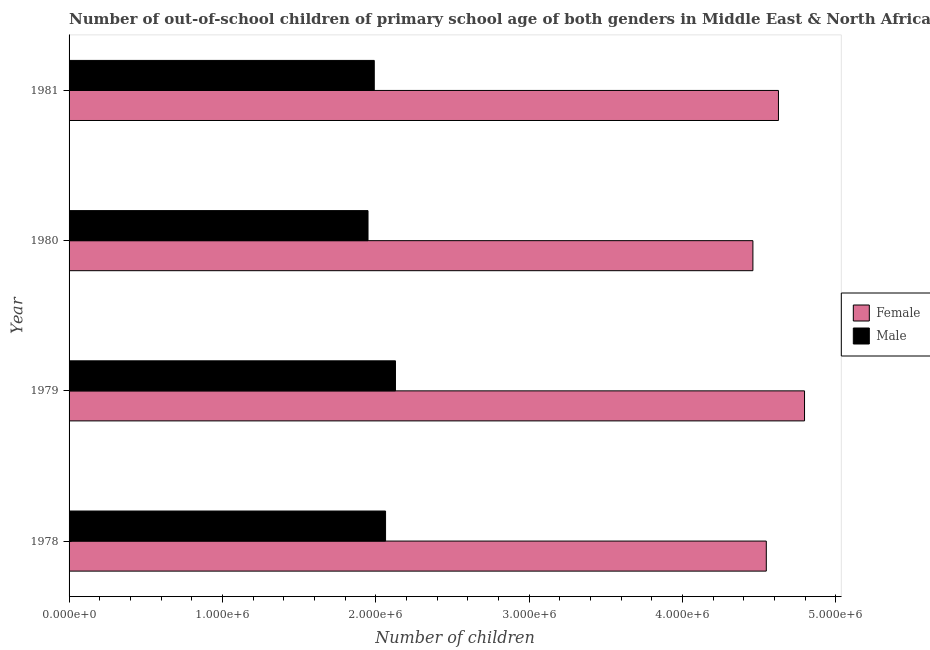How many bars are there on the 2nd tick from the top?
Offer a very short reply. 2. How many bars are there on the 3rd tick from the bottom?
Your response must be concise. 2. What is the label of the 3rd group of bars from the top?
Your answer should be very brief. 1979. In how many cases, is the number of bars for a given year not equal to the number of legend labels?
Ensure brevity in your answer.  0. What is the number of female out-of-school students in 1978?
Make the answer very short. 4.55e+06. Across all years, what is the maximum number of female out-of-school students?
Make the answer very short. 4.80e+06. Across all years, what is the minimum number of female out-of-school students?
Provide a succinct answer. 4.46e+06. In which year was the number of female out-of-school students maximum?
Offer a very short reply. 1979. What is the total number of female out-of-school students in the graph?
Your answer should be very brief. 1.84e+07. What is the difference between the number of female out-of-school students in 1978 and that in 1979?
Your answer should be very brief. -2.49e+05. What is the difference between the number of male out-of-school students in 1979 and the number of female out-of-school students in 1978?
Ensure brevity in your answer.  -2.42e+06. What is the average number of female out-of-school students per year?
Your response must be concise. 4.61e+06. In the year 1979, what is the difference between the number of male out-of-school students and number of female out-of-school students?
Provide a succinct answer. -2.67e+06. What is the ratio of the number of female out-of-school students in 1978 to that in 1979?
Give a very brief answer. 0.95. Is the number of female out-of-school students in 1979 less than that in 1980?
Your response must be concise. No. What is the difference between the highest and the second highest number of female out-of-school students?
Provide a succinct answer. 1.70e+05. What is the difference between the highest and the lowest number of male out-of-school students?
Your answer should be very brief. 1.79e+05. In how many years, is the number of male out-of-school students greater than the average number of male out-of-school students taken over all years?
Your response must be concise. 2. What does the 2nd bar from the top in 1979 represents?
Provide a short and direct response. Female. What does the 2nd bar from the bottom in 1981 represents?
Offer a very short reply. Male. How many bars are there?
Your response must be concise. 8. Are all the bars in the graph horizontal?
Make the answer very short. Yes. Are the values on the major ticks of X-axis written in scientific E-notation?
Your answer should be very brief. Yes. How many legend labels are there?
Offer a very short reply. 2. How are the legend labels stacked?
Your answer should be compact. Vertical. What is the title of the graph?
Give a very brief answer. Number of out-of-school children of primary school age of both genders in Middle East & North Africa (developing only). Does "Fertility rate" appear as one of the legend labels in the graph?
Your answer should be compact. No. What is the label or title of the X-axis?
Ensure brevity in your answer.  Number of children. What is the Number of children in Female in 1978?
Provide a short and direct response. 4.55e+06. What is the Number of children of Male in 1978?
Provide a short and direct response. 2.06e+06. What is the Number of children in Female in 1979?
Provide a succinct answer. 4.80e+06. What is the Number of children in Male in 1979?
Give a very brief answer. 2.13e+06. What is the Number of children in Female in 1980?
Your answer should be compact. 4.46e+06. What is the Number of children of Male in 1980?
Your response must be concise. 1.95e+06. What is the Number of children in Female in 1981?
Your answer should be compact. 4.63e+06. What is the Number of children of Male in 1981?
Your answer should be very brief. 1.99e+06. Across all years, what is the maximum Number of children of Female?
Give a very brief answer. 4.80e+06. Across all years, what is the maximum Number of children of Male?
Give a very brief answer. 2.13e+06. Across all years, what is the minimum Number of children in Female?
Provide a short and direct response. 4.46e+06. Across all years, what is the minimum Number of children in Male?
Your answer should be very brief. 1.95e+06. What is the total Number of children of Female in the graph?
Your answer should be compact. 1.84e+07. What is the total Number of children of Male in the graph?
Your answer should be very brief. 8.13e+06. What is the difference between the Number of children of Female in 1978 and that in 1979?
Offer a very short reply. -2.49e+05. What is the difference between the Number of children in Male in 1978 and that in 1979?
Make the answer very short. -6.46e+04. What is the difference between the Number of children of Female in 1978 and that in 1980?
Offer a very short reply. 8.73e+04. What is the difference between the Number of children in Male in 1978 and that in 1980?
Give a very brief answer. 1.14e+05. What is the difference between the Number of children of Female in 1978 and that in 1981?
Offer a very short reply. -7.93e+04. What is the difference between the Number of children of Male in 1978 and that in 1981?
Your answer should be very brief. 7.36e+04. What is the difference between the Number of children in Female in 1979 and that in 1980?
Provide a short and direct response. 3.37e+05. What is the difference between the Number of children in Male in 1979 and that in 1980?
Give a very brief answer. 1.79e+05. What is the difference between the Number of children of Female in 1979 and that in 1981?
Offer a very short reply. 1.70e+05. What is the difference between the Number of children of Male in 1979 and that in 1981?
Keep it short and to the point. 1.38e+05. What is the difference between the Number of children in Female in 1980 and that in 1981?
Your answer should be very brief. -1.67e+05. What is the difference between the Number of children in Male in 1980 and that in 1981?
Your answer should be compact. -4.07e+04. What is the difference between the Number of children in Female in 1978 and the Number of children in Male in 1979?
Offer a terse response. 2.42e+06. What is the difference between the Number of children in Female in 1978 and the Number of children in Male in 1980?
Keep it short and to the point. 2.60e+06. What is the difference between the Number of children in Female in 1978 and the Number of children in Male in 1981?
Offer a terse response. 2.56e+06. What is the difference between the Number of children of Female in 1979 and the Number of children of Male in 1980?
Ensure brevity in your answer.  2.85e+06. What is the difference between the Number of children in Female in 1979 and the Number of children in Male in 1981?
Provide a succinct answer. 2.81e+06. What is the difference between the Number of children of Female in 1980 and the Number of children of Male in 1981?
Offer a terse response. 2.47e+06. What is the average Number of children in Female per year?
Make the answer very short. 4.61e+06. What is the average Number of children of Male per year?
Ensure brevity in your answer.  2.03e+06. In the year 1978, what is the difference between the Number of children in Female and Number of children in Male?
Provide a succinct answer. 2.48e+06. In the year 1979, what is the difference between the Number of children in Female and Number of children in Male?
Provide a short and direct response. 2.67e+06. In the year 1980, what is the difference between the Number of children of Female and Number of children of Male?
Your answer should be very brief. 2.51e+06. In the year 1981, what is the difference between the Number of children of Female and Number of children of Male?
Your answer should be compact. 2.64e+06. What is the ratio of the Number of children in Female in 1978 to that in 1979?
Your answer should be compact. 0.95. What is the ratio of the Number of children of Male in 1978 to that in 1979?
Ensure brevity in your answer.  0.97. What is the ratio of the Number of children in Female in 1978 to that in 1980?
Provide a short and direct response. 1.02. What is the ratio of the Number of children of Male in 1978 to that in 1980?
Make the answer very short. 1.06. What is the ratio of the Number of children in Female in 1978 to that in 1981?
Make the answer very short. 0.98. What is the ratio of the Number of children of Male in 1978 to that in 1981?
Keep it short and to the point. 1.04. What is the ratio of the Number of children in Female in 1979 to that in 1980?
Keep it short and to the point. 1.08. What is the ratio of the Number of children in Male in 1979 to that in 1980?
Provide a short and direct response. 1.09. What is the ratio of the Number of children of Female in 1979 to that in 1981?
Provide a short and direct response. 1.04. What is the ratio of the Number of children in Male in 1979 to that in 1981?
Your answer should be compact. 1.07. What is the ratio of the Number of children of Male in 1980 to that in 1981?
Keep it short and to the point. 0.98. What is the difference between the highest and the second highest Number of children in Female?
Offer a terse response. 1.70e+05. What is the difference between the highest and the second highest Number of children of Male?
Ensure brevity in your answer.  6.46e+04. What is the difference between the highest and the lowest Number of children in Female?
Your answer should be very brief. 3.37e+05. What is the difference between the highest and the lowest Number of children of Male?
Ensure brevity in your answer.  1.79e+05. 